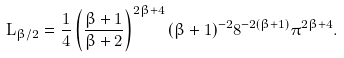Convert formula to latex. <formula><loc_0><loc_0><loc_500><loc_500>L _ { \beta / 2 } = \frac { 1 } { 4 } \left ( \frac { \beta + 1 } { \beta + 2 } \right ) ^ { 2 \beta + 4 } ( \beta + 1 ) ^ { - 2 } 8 ^ { - 2 ( \beta + 1 ) } \pi ^ { 2 \beta + 4 } .</formula> 